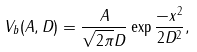<formula> <loc_0><loc_0><loc_500><loc_500>V _ { b } ( A , D ) = \frac { A } { \sqrt { 2 \pi } D } \exp { \frac { - x ^ { 2 } } { 2 D ^ { 2 } } } ,</formula> 